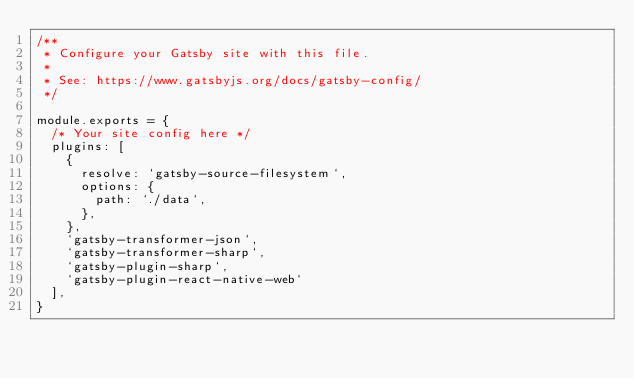Convert code to text. <code><loc_0><loc_0><loc_500><loc_500><_JavaScript_>/**
 * Configure your Gatsby site with this file.
 *
 * See: https://www.gatsbyjs.org/docs/gatsby-config/
 */

module.exports = {
  /* Your site config here */
  plugins: [
    {
      resolve: `gatsby-source-filesystem`,
      options: {
        path: `./data`,
      },
    },
    `gatsby-transformer-json`,
    `gatsby-transformer-sharp`, 
    `gatsby-plugin-sharp`,
    `gatsby-plugin-react-native-web`
  ],
}
</code> 